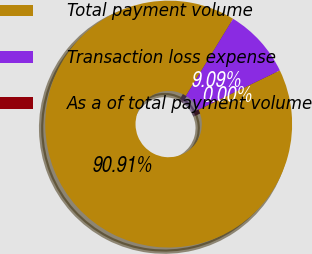Convert chart to OTSL. <chart><loc_0><loc_0><loc_500><loc_500><pie_chart><fcel>Total payment volume<fcel>Transaction loss expense<fcel>As a of total payment volume<nl><fcel>90.91%<fcel>9.09%<fcel>0.0%<nl></chart> 